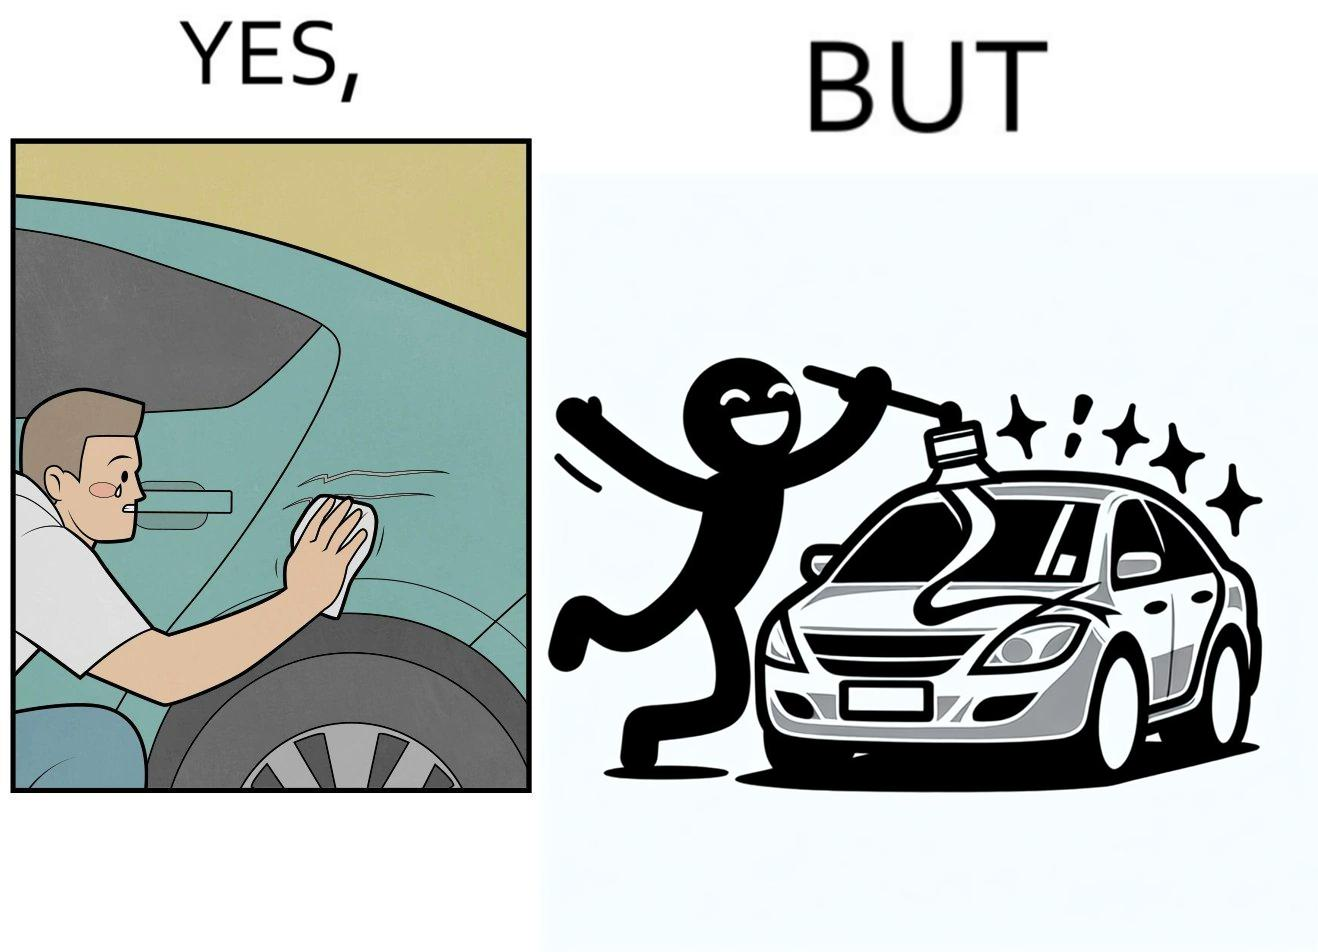What is shown in the left half versus the right half of this image? In the left part of the image: a person is trying to remove the scratches on his car while crying on them In the right part of the image: a person happily applies car decal or some logo on his car to make it look stylish 